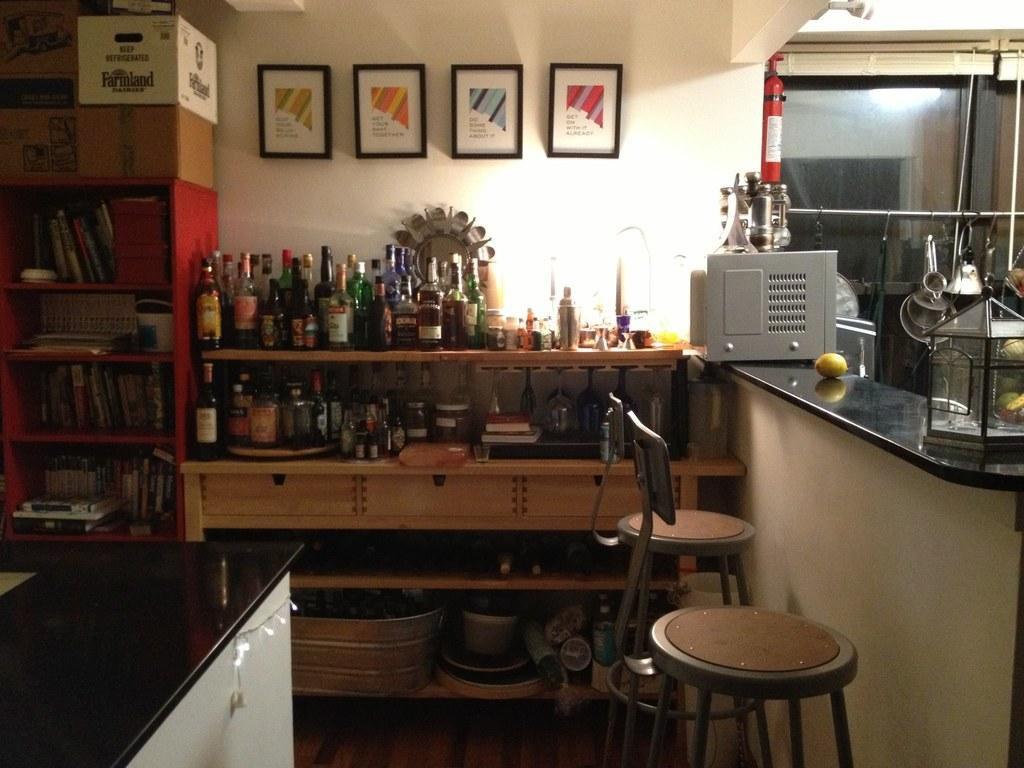What type of space is shown in the image? The image is an inside view of a room. What objects can be seen in the room? There are bottles, a frame, boxes, books, a table, a chair, a container, vessels, fruit, and an extinguisher in the room. What structural elements are present in the room? There is a wall, a window, a floor, and a roof in the room. How much dust can be seen on the furniture in the image? There is no furniture present in the image, so it is not possible to determine the amount of dust on it. 